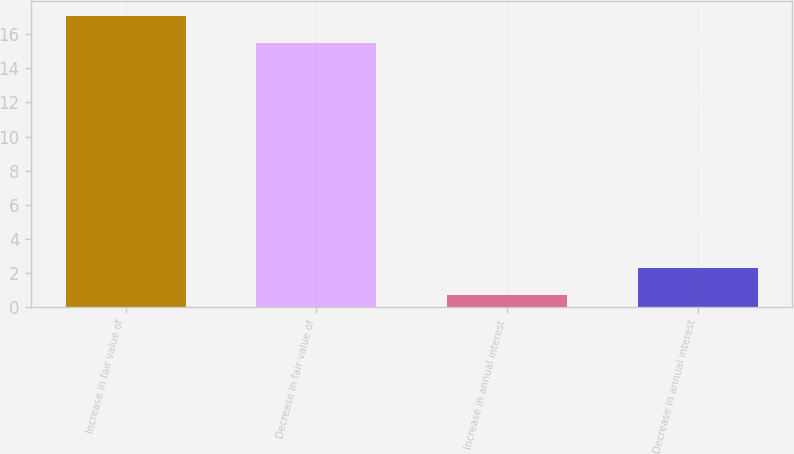Convert chart. <chart><loc_0><loc_0><loc_500><loc_500><bar_chart><fcel>Increase in fair value of<fcel>Decrease in fair value of<fcel>Increase in annual interest<fcel>Decrease in annual interest<nl><fcel>17.1<fcel>15.5<fcel>0.7<fcel>2.3<nl></chart> 